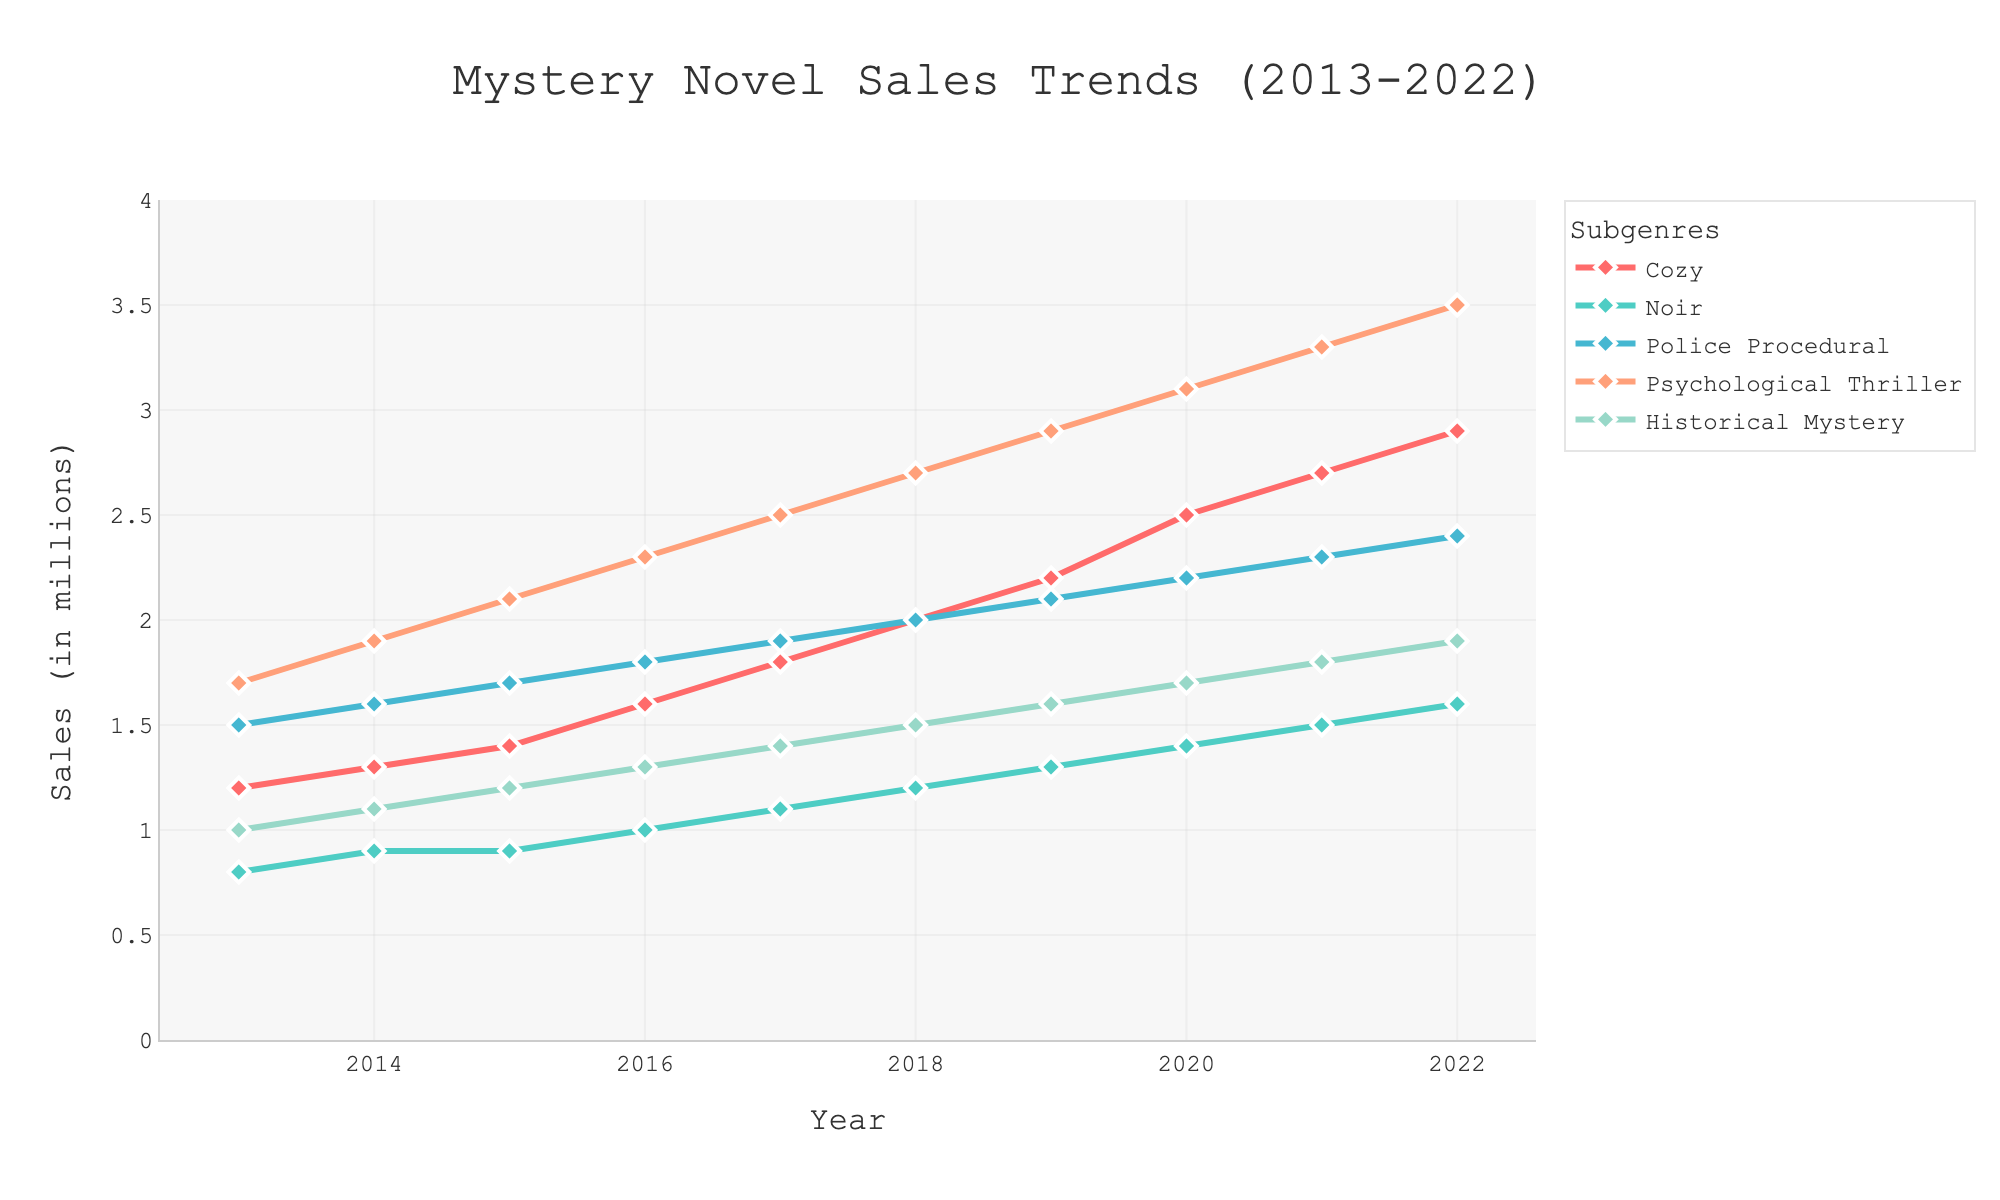What is the overall trend in sales for the Cozy subgenre from 2013 to 2022? From 2013 to 2022, the sales for the Cozy subgenre depict a clear upward trend. This can be observed by looking at the line representing the Cozy subgenre, which ascends from 1.2 million in 2013 to 2.9 million in 2022. This steady increase in value indicates a consistent growth.
Answer: Upward trend Which subgenre experienced the highest increase in sales between the years 2013 and 2022? To determine the highest increase, we need to compute the difference between sales in 2022 and 2013 for each subgenre. For Cozy, it's 2.9 - 1.2 = 1.7; for Noir, it's 1.6 - 0.8 = 0.8; for Police Procedural, it's 2.4 - 1.5 = 0.9; for Psychological Thriller, it's 3.5 - 1.7 = 1.8; for Historical Mystery, it's 1.9 - 1.0 = 0.9. By comparing these differences, we find that Psychological Thriller experienced the highest increase of 1.8 million.
Answer: Psychological Thriller In which year did the Police Procedural subgenre sales exceed 2 million? To determine this, we need to look at the points along the line representing Police Procedural subgenre sales. The sales exceed 2 million from the year 2018 onwards, as visible from the data points: 2.0 in 2018, 2.1 in 2019, 2.2 in 2020, 2.3 in 2021, and 2.4 in 2022.
Answer: 2018 Among the subgenres, which one had the lowest sales in 2022 and what was the value? By examining the endpoint values for each subgenre in 2022, Noir shows the lowest value. Visual comparison with the other lines confirms this observation. The sales value for Noir in 2022 is 1.6 million.
Answer: Noir, 1.6 million How did the sales for the Historical Mystery subgenre change from 2016 to 2018? We need to compare the values for the Historical Mystery subgenre between 2016 and 2018. In 2016, the sales were 1.3 million, and in 2018, it was 1.5 million. Hence, the sales increased from 1.3 million to 1.5 million over these two years.
Answer: Increased by 0.2 million Which subgenre had a consistent year-over-year increase in sales throughout the given period? By examining the lines on the chart, we see that both the Cozy and Psychological Thriller subgenres have continuous upward trajectories without any dips throughout the decade.
Answer: Cozy and Psychological Thriller What is the average annual sales of the Cozy subgenre between 2013 and 2022? To find the average, sum the sales values of the Cozy subgenre from 2013 to 2022 and divide by the number of years. The sum is 1.2 + 1.3 + 1.4 + 1.6 + 1.8 + 2.0 + 2.2 + 2.5 + 2.7 + 2.9 = 19.6. Dividing this by 10 years, the average is 19.6 / 10 = 1.96 million.
Answer: 1.96 million In which year did the sales for Noir subgenre reach 1.0 million and what was the trend around this year? Referring to the line representing Noir's sales, we see that it reaches 1.0 million in the year 2016. Before 2016, the sales were below 1.0 million, and they continuously increased afterward.
Answer: 2016, upward trend 